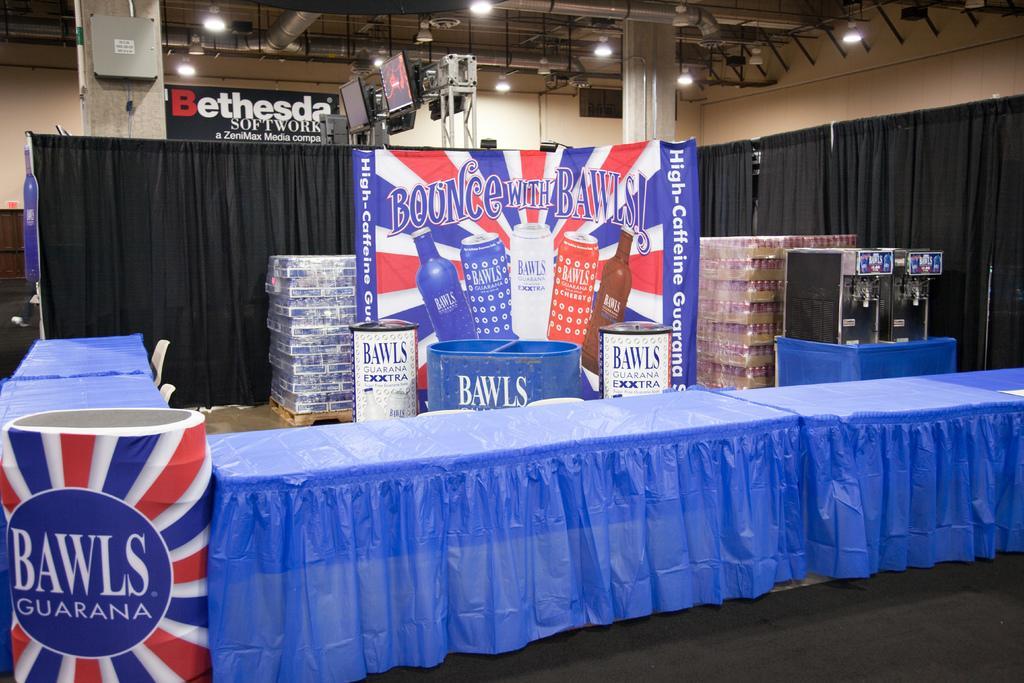In one or two sentences, can you explain what this image depicts? In this image there is are tables, there are clothes on the tables, there is a board, there is text on the board, there are curtains, there are pillars, there are televisions, there is the roof towards the top of the image, there are lights on the roof, there is the wall, there are chairs, there are objects on the ground, there are objects on the table. 